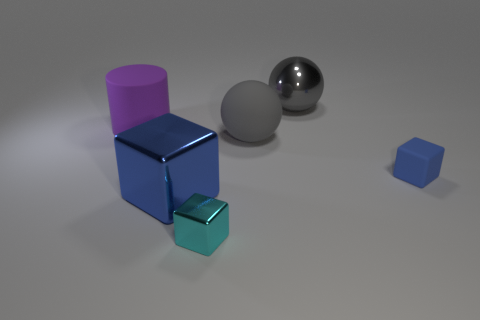Can you describe the textures of the objects in the image? Certainly! The large blue cube in the center seems to have a reflective, polished surface with subtle surface imperfections, indicating a metallic material. The purple cylinder appears smooth, likely made of a matte plastic or painted surface. The small cyan cube and the larger gray sphere both seem to have high-gloss metallic finishes, while the smallest blue cube has a similar finish to the larger blue cube. 